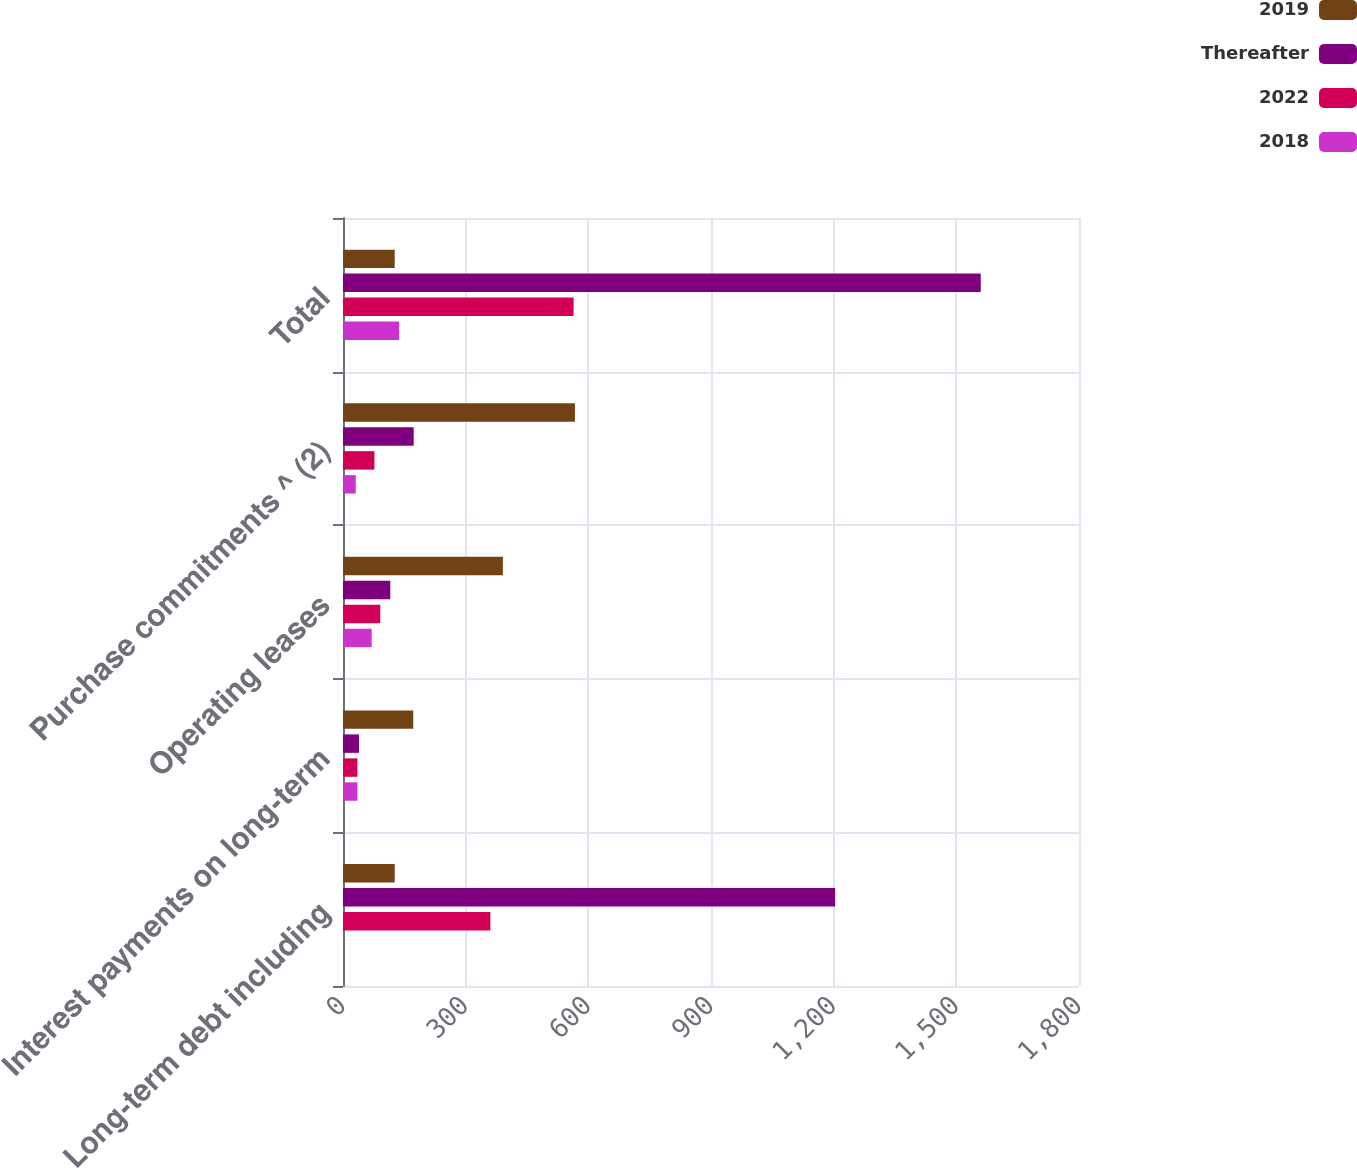<chart> <loc_0><loc_0><loc_500><loc_500><stacked_bar_chart><ecel><fcel>Long-term debt including<fcel>Interest payments on long-term<fcel>Operating leases<fcel>Purchase commitments ^ (2)<fcel>Total<nl><fcel>2019<fcel>126.45<fcel>171.8<fcel>391<fcel>567.2<fcel>126.45<nl><fcel>Thereafter<fcel>1203.7<fcel>39.1<fcel>115.7<fcel>172.9<fcel>1559.7<nl><fcel>2022<fcel>360.5<fcel>35.3<fcel>91.2<fcel>76.9<fcel>563.9<nl><fcel>2018<fcel>0.6<fcel>35.3<fcel>70.1<fcel>31.2<fcel>137.2<nl></chart> 